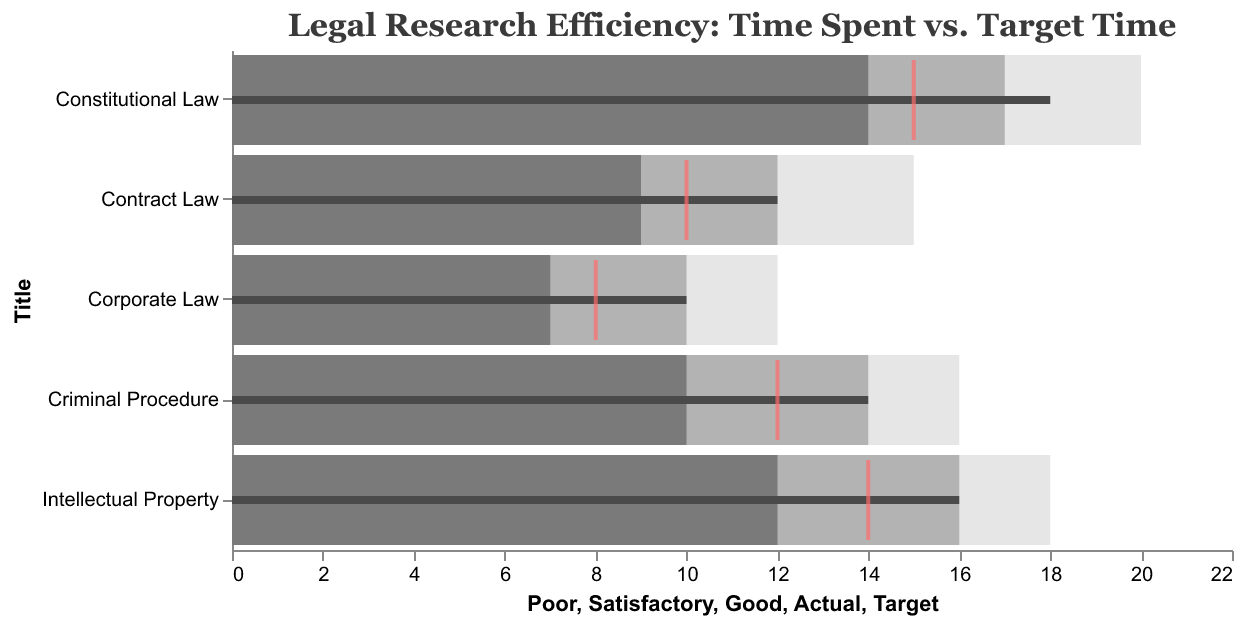Which subject has the highest actual time spent? To find this, look for the maximum value in the 'Actual' column. The highest actual time spent is 18 hours, which corresponds to "Constitutional Law."
Answer: Constitutional Law Which subject's actual time spent is closest to the target time? Compare the differences between the 'Actual' and 'Target' time for each subject. "Constitutional Law" has a difference of 3 hours, "Contract Law" has a difference of 2 hours, "Criminal Procedure" has a difference of 2 hours, "Intellectual Property" has a difference of 2 hours, and "Corporate Law" has a difference of 2 hours. Thus, "Contract Law," "Criminal Procedure," "Intellectual Property," and "Corporate Law" are equally closest to the target time with a difference of 2 hours.
Answer: Contract Law, Criminal Procedure, Intellectual Property, Corporate Law How many subjects have an actual time spent that exceeds the target time? For this, count the number of subjects where the 'Actual' value is greater than the 'Target' value. In this case, all subjects have actual times exceeding the target: "Constitutional Law" (18 > 15), "Contract Law" (12 > 10), "Criminal Procedure" (14 > 12), "Intellectual Property" (16 > 14), "Corporate Law" (10 > 8). Hence, all 5 subjects have actual times exceeding the target.
Answer: 5 Which subject has the smallest difference between actual and good performance time? Calculate the differences between 'Actual' and 'Good' for each subject. For "Constitutional Law" (18 - 14 = 4), "Contract Law" (12 - 9 = 3), "Criminal Procedure" (14 - 10 = 4), "Intellectual Property" (16 - 12 = 4), "Corporate Law" (10 - 7 = 3). The smallest differences are for "Contract Law" and "Corporate Law," each with a difference of 3 hours.
Answer: Contract Law, Corporate Law Which subjects fall into the 'Poor' performance category based on actual time spent? Compare the actual time spent with the 'Poor' performance threshold. If the actual time is more than or equal to the 'Poor' value, it is categorized as poor. None of the actual times meet the 'Poor' performance threshold in this dataset.
Answer: None 